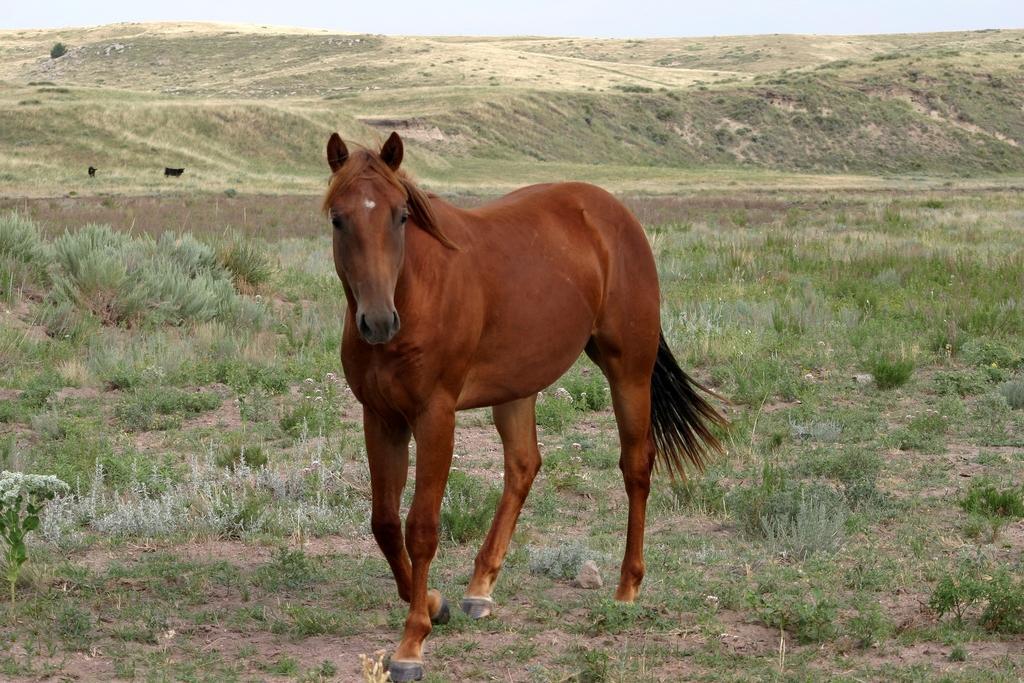Please provide a concise description of this image. In this image I can see an animal in brown color. In the background I can see the plants in green color and the sky is in white color. 